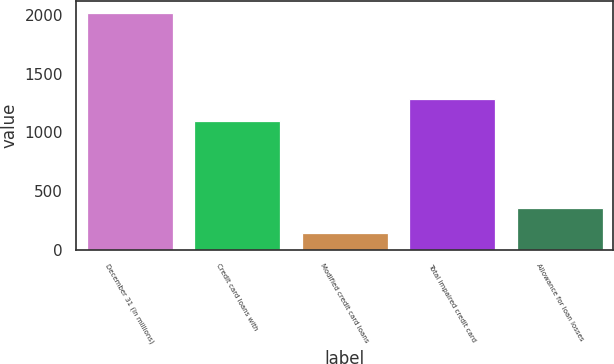Convert chart to OTSL. <chart><loc_0><loc_0><loc_500><loc_500><bar_chart><fcel>December 31 (in millions)<fcel>Credit card loans with<fcel>Modified credit card loans<fcel>Total impaired credit card<fcel>Allowance for loan losses<nl><fcel>2016<fcel>1098<fcel>142<fcel>1285.4<fcel>358<nl></chart> 